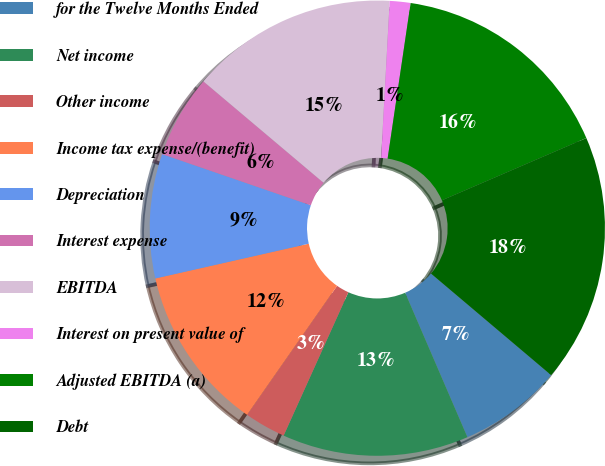Convert chart. <chart><loc_0><loc_0><loc_500><loc_500><pie_chart><fcel>for the Twelve Months Ended<fcel>Net income<fcel>Other income<fcel>Income tax expense/(benefit)<fcel>Depreciation<fcel>Interest expense<fcel>EBITDA<fcel>Interest on present value of<fcel>Adjusted EBITDA (a)<fcel>Debt<nl><fcel>7.35%<fcel>13.23%<fcel>2.94%<fcel>11.76%<fcel>8.82%<fcel>5.88%<fcel>14.71%<fcel>1.47%<fcel>16.18%<fcel>17.65%<nl></chart> 